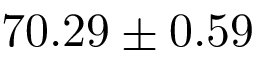Convert formula to latex. <formula><loc_0><loc_0><loc_500><loc_500>7 0 . 2 9 \pm 0 . 5 9</formula> 